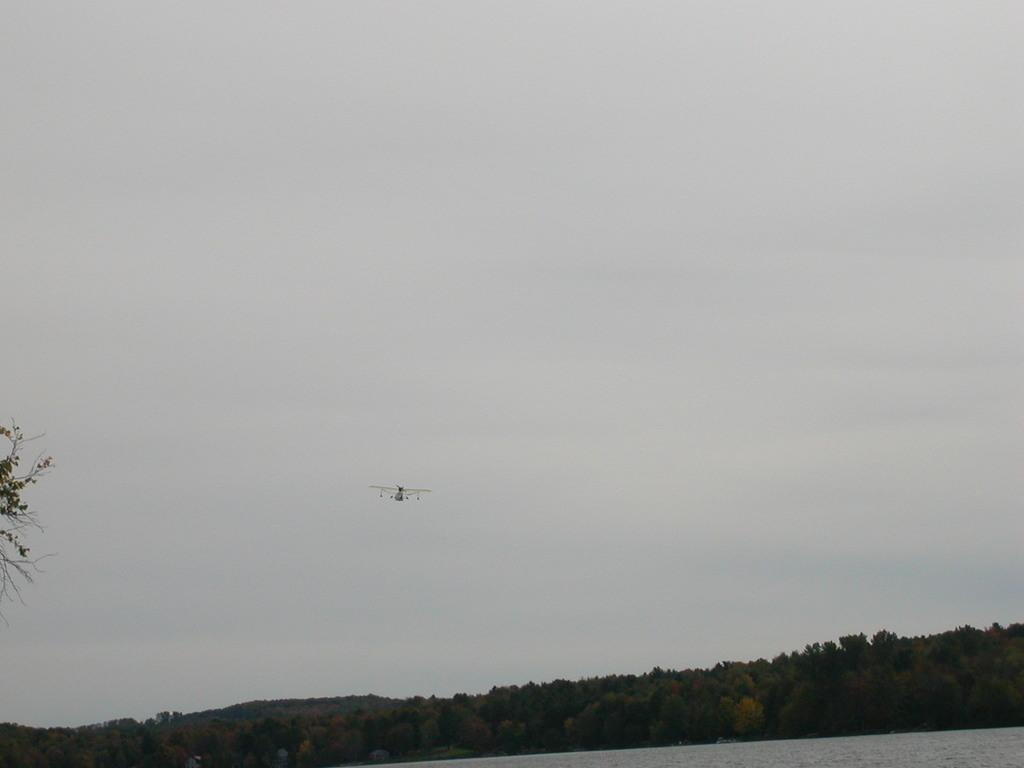What is the main subject of the image? The main subject of the image is a plane flying in the air. What can be seen in the background of the image? There are trees in the background of the image. How many legs can be seen on the bird in the image? There is no bird present in the image, so it is not possible to determine the number of legs. 